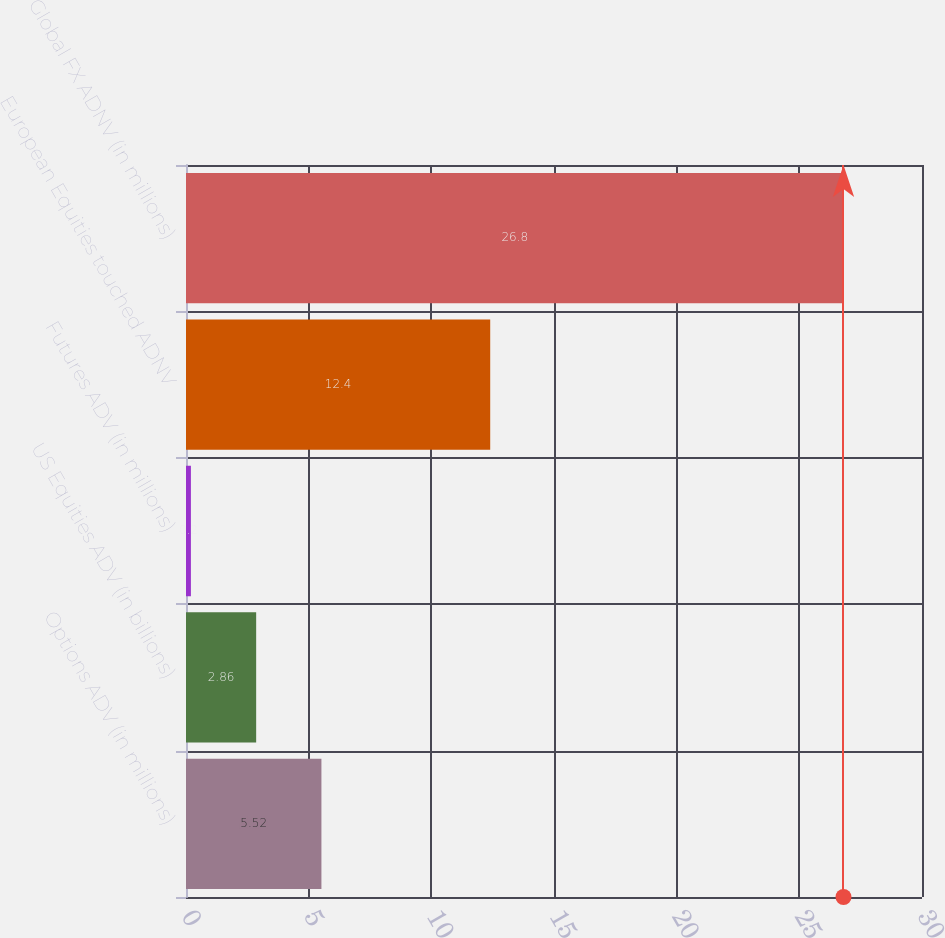Convert chart to OTSL. <chart><loc_0><loc_0><loc_500><loc_500><bar_chart><fcel>Options ADV (in millions)<fcel>US Equities ADV (in billions)<fcel>Futures ADV (in millions)<fcel>European Equities touched ADNV<fcel>Global FX ADNV (in millions)<nl><fcel>5.52<fcel>2.86<fcel>0.2<fcel>12.4<fcel>26.8<nl></chart> 